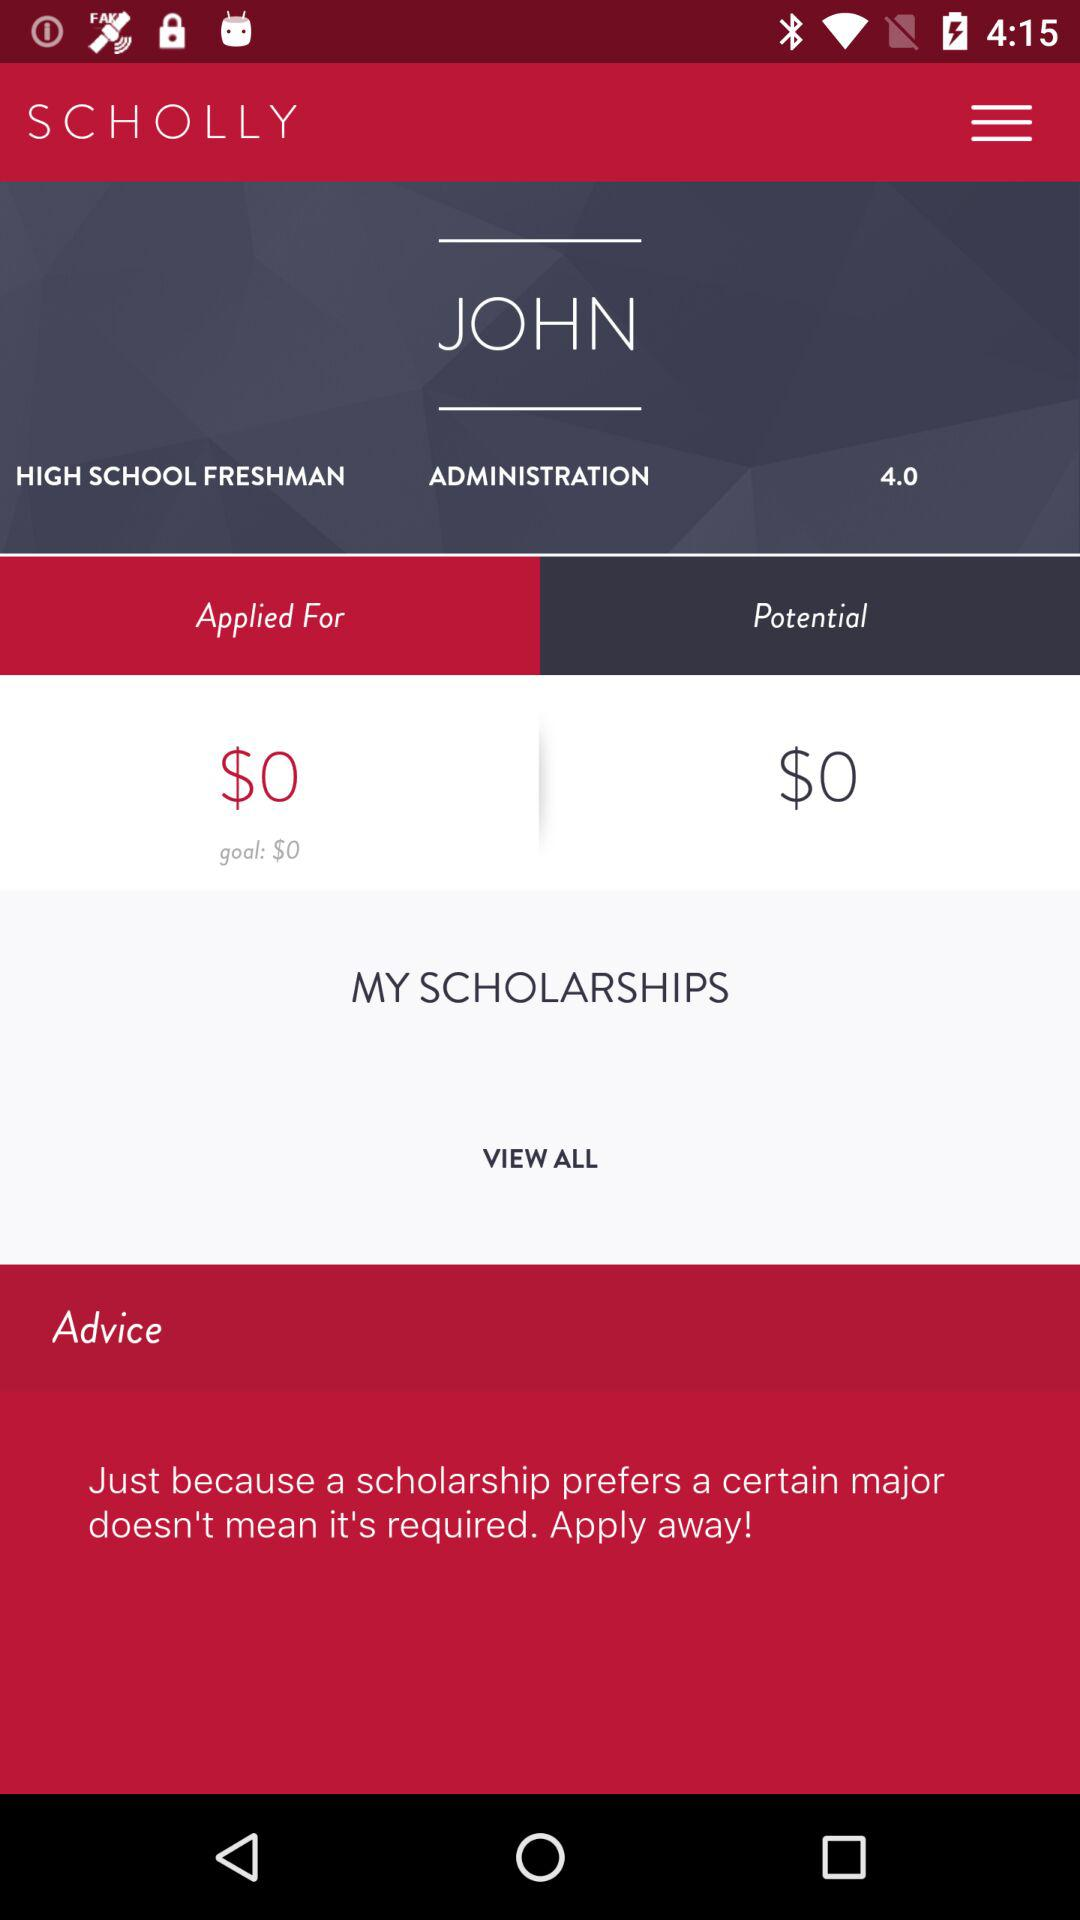What is the total amount for the goal? The total amount for the goal is $0. 